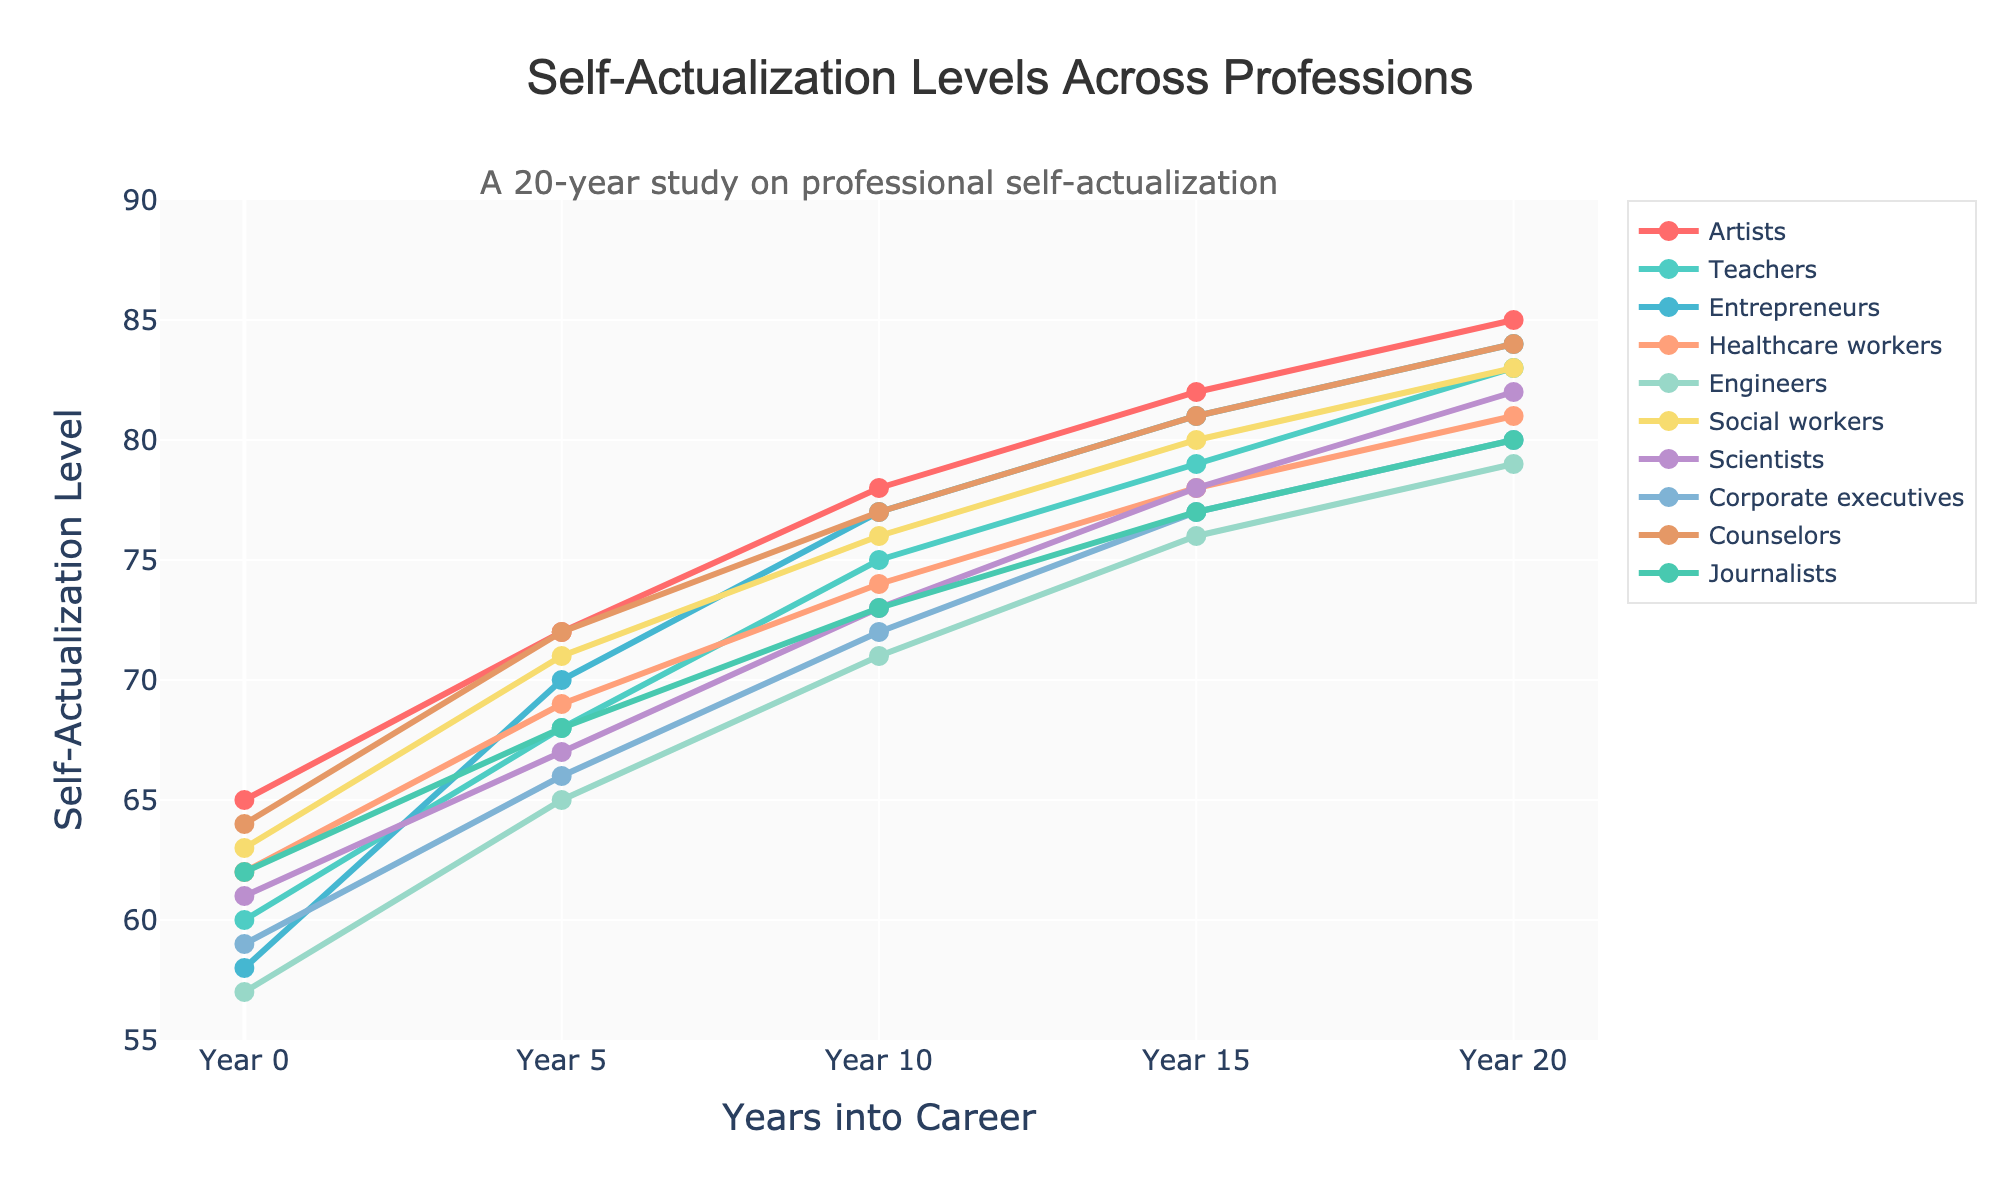Which profession started with the highest self-actualization level? From the figure, observe the y-values at Year 0 for all data series. The highest starting value belongs to Artists with 65.
Answer: Artists Between Year 15 and Year 20, which profession showed the highest increase in self-actualization level? Compare the differences in y-values between Year 15 and Year 20. Engineers increased by 3, while other professions increased marginally higher, like Artists (3). The highest increase is Artists.
Answer: Artists How much did the self-actualization level of Entrepreneurs change from Year 0 to Year 10? Subtract the self-actualization level at Year 0 from the level at Year 10 for Entrepreneurs: [77 - 58].
Answer: 19 By how much did the self-actualization level of Social Workers differ from that of Scientists in Year 5? Find the self-actualization levels at Year 5 for Social Workers and Scientists (71 and 67, respectively) and calculate the difference: [71 - 67].
Answer: 4 What is the average self-actualization level of Healthcare Workers over the 20-year span? Add the self-actualization levels of Healthcare Workers over all years and divide by the number of years: (62 + 69 + 74 + 78 + 81) / 5.
Answer: 72.8 Which profession had the second-highest self-actualization level at Year 20? Check the y-values for all professions at Year 20, and note the second-highest value after Artists (85) is Entrepreneurs and Counselors (84).
Answer: Entrepreneurs, Counselors How do the self-actualization levels of Teachers compare to Corporate Executives at Year 10? Compare the y-values for Teachers (75) and Corporate Executives (72) at Year 10. Teachers have a higher value by 3 points.
Answer: Teachers are 3 points higher Is there a profession whose self-actualization level remained the same between any consecutive years? Examine the y-values of all professions between consecutive years. None of the professions have equal values between any consecutive years.
Answer: No Compare the self-actualization trajectory of Artists and Engineers. Which had a steeper increase at the beginning of their careers? Compare the changes in self-actualization levels from Year 0 to Year 5 for Artists (72 - 65 = 7) and Engineers (65 - 57 = 8). Engineers had a steeper increase.
Answer: Engineers What trend do we observe in the self-actualization levels of Counselors from Year 0 to Year 20? Observe the line plot for Counselors. The trend shows a gradual increase across all points from Year 0 (64) to Year 20 (84).
Answer: Gradual increase 